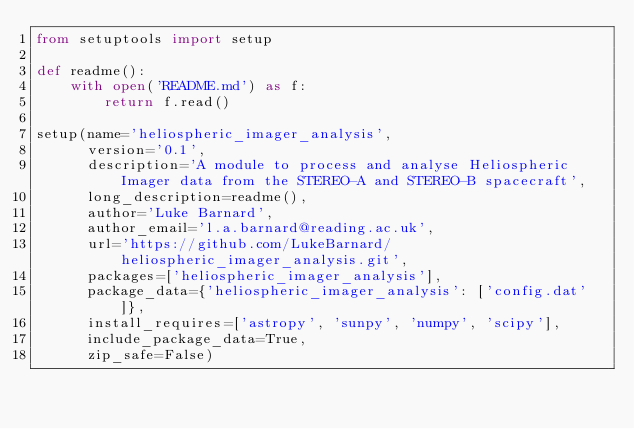Convert code to text. <code><loc_0><loc_0><loc_500><loc_500><_Python_>from setuptools import setup

def readme():
    with open('README.md') as f:
        return f.read()

setup(name='heliospheric_imager_analysis',
      version='0.1',
      description='A module to process and analyse Heliospheric Imager data from the STEREO-A and STEREO-B spacecraft',
      long_description=readme(),
      author='Luke Barnard',
      author_email='l.a.barnard@reading.ac.uk',
      url='https://github.com/LukeBarnard/heliospheric_imager_analysis.git',
      packages=['heliospheric_imager_analysis'],
      package_data={'heliospheric_imager_analysis': ['config.dat']},
      install_requires=['astropy', 'sunpy', 'numpy', 'scipy'],
      include_package_data=True,
      zip_safe=False)</code> 